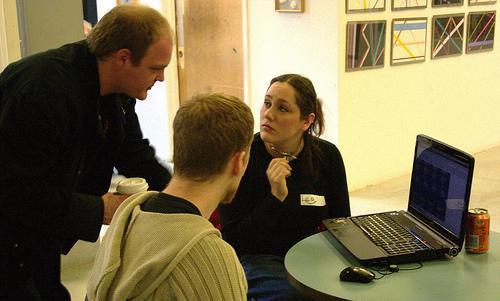How many people are shown?
Give a very brief answer. 3. 